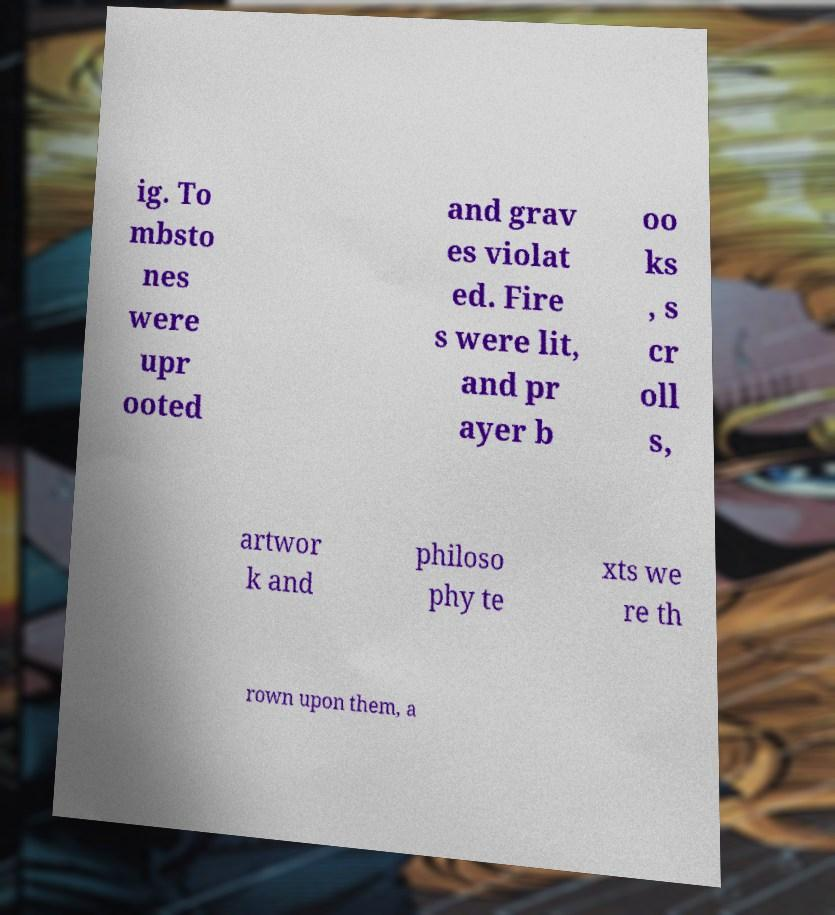What messages or text are displayed in this image? I need them in a readable, typed format. ig. To mbsto nes were upr ooted and grav es violat ed. Fire s were lit, and pr ayer b oo ks , s cr oll s, artwor k and philoso phy te xts we re th rown upon them, a 